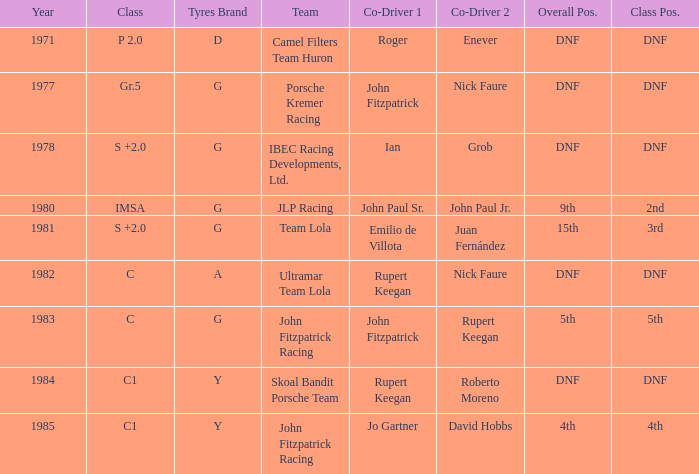What is the earliest year that had a co-driver of Roger Enever? 1971.0. 